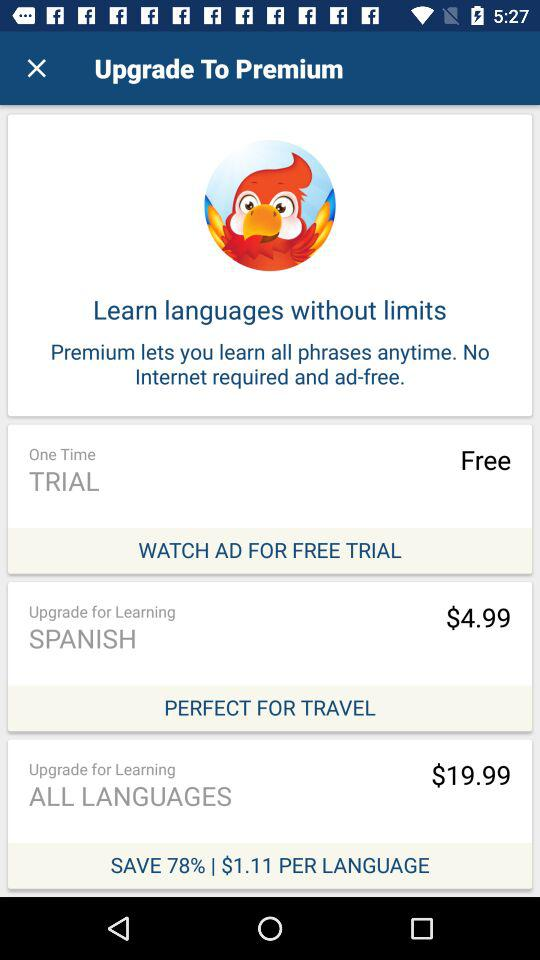What is the cost of the upgrade for learning all languages? The cost of the upgrade for learning all languages is $19.99. 